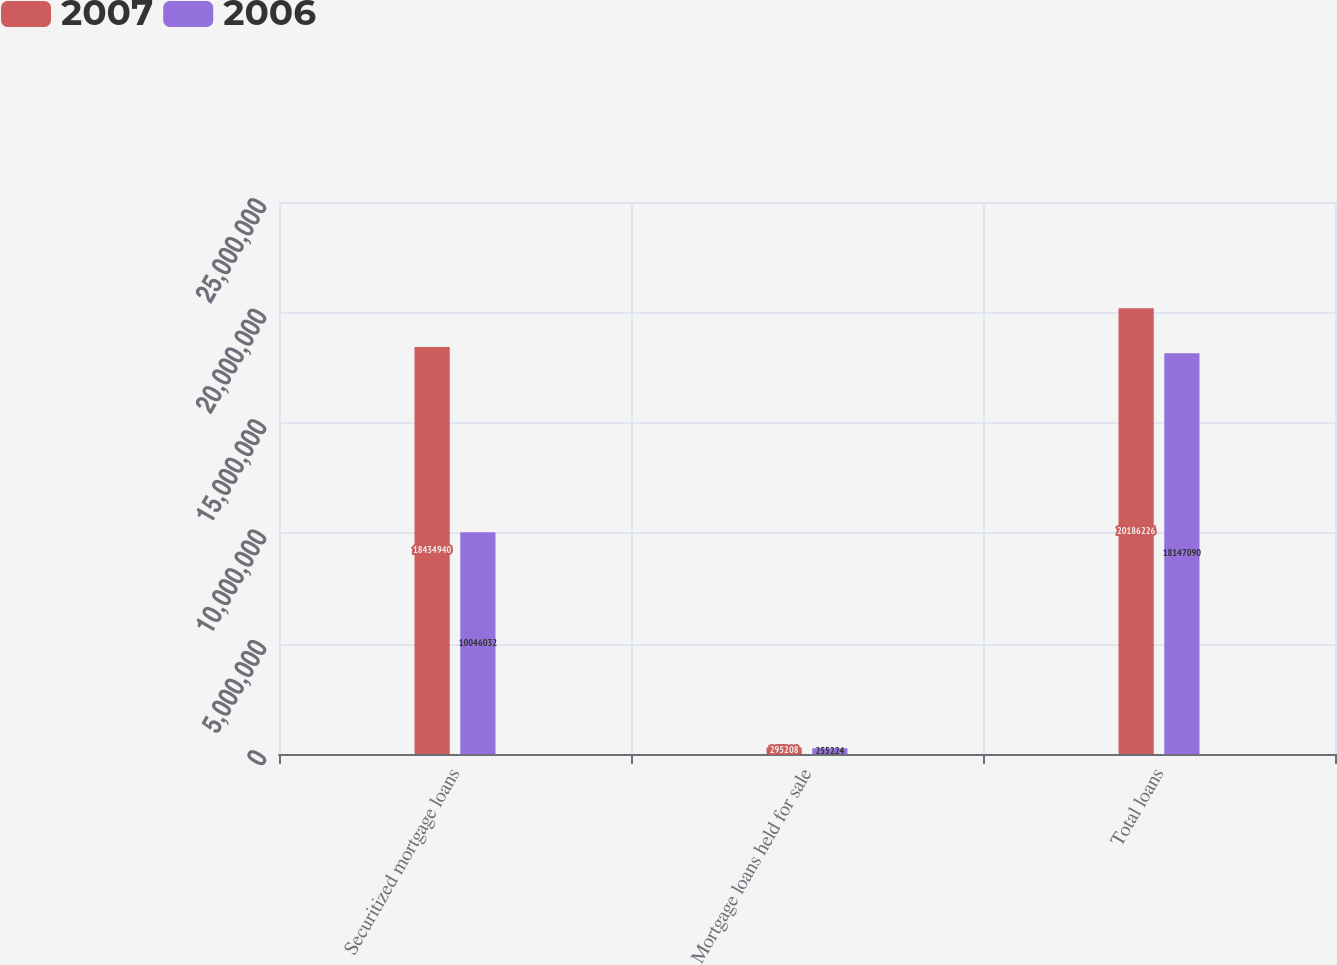Convert chart to OTSL. <chart><loc_0><loc_0><loc_500><loc_500><stacked_bar_chart><ecel><fcel>Securitized mortgage loans<fcel>Mortgage loans held for sale<fcel>Total loans<nl><fcel>2007<fcel>1.84349e+07<fcel>295208<fcel>2.01862e+07<nl><fcel>2006<fcel>1.0046e+07<fcel>255224<fcel>1.81471e+07<nl></chart> 